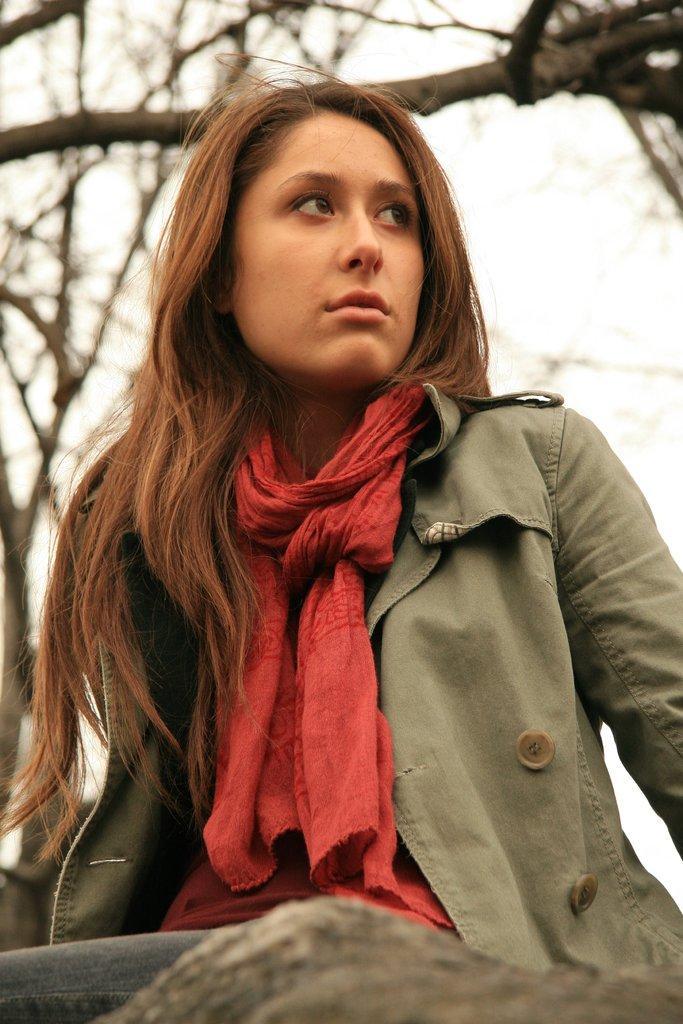Describe this image in one or two sentences. In this picture, we see the girl who is wearing the jacket and the red scarf is sitting. At the bottom, it looks like a stone. There are trees in the background. In the background, we see the sky. 